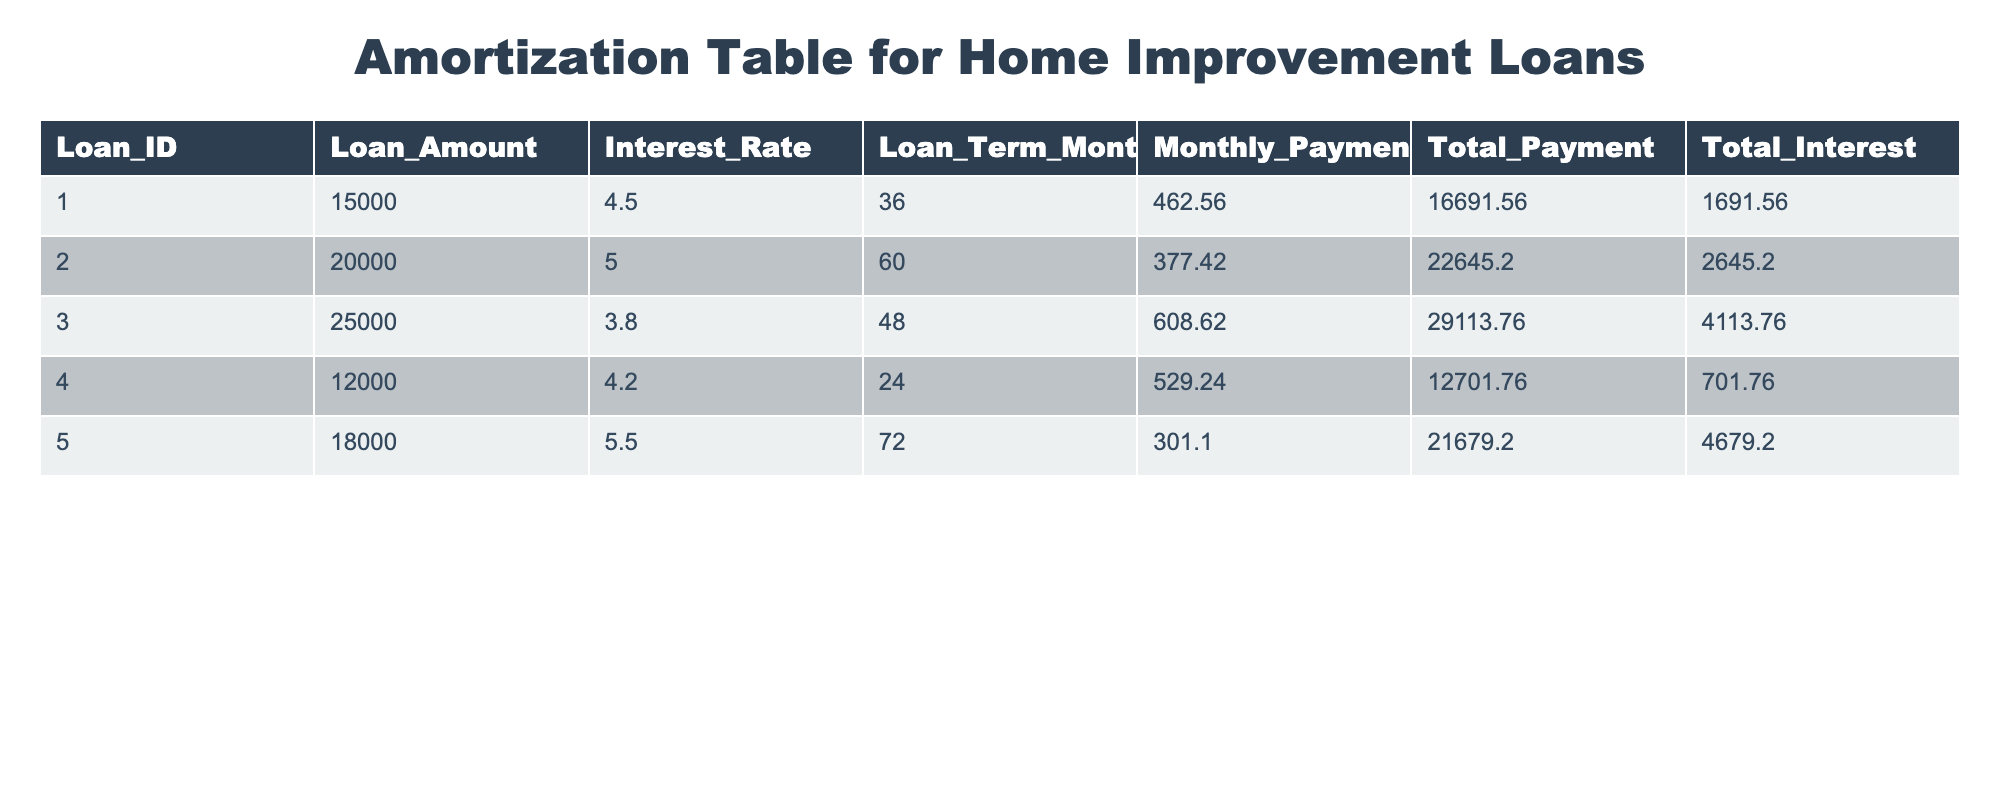What is the loan amount for Loan ID 3? From the table, we look for the row corresponding to Loan ID 3, which shows the Loan Amount as 25000.
Answer: 25000 What is the total interest paid on Loan ID 5? Referring to Loan ID 5 in the table, we see that the Total Interest is 4679.20.
Answer: 4679.20 Which loan has the highest total payment? By comparing the Total Payment values in the table, Loan ID 5 has the highest total payment of 21679.20.
Answer: Loan ID 5 Is the interest rate for Loan ID 2 higher than for Loan ID 1? Looking at the Interest Rate column, Loan ID 2 has an interest rate of 5.0, while Loan ID 1 has 4.5. Since 5.0 is greater than 4.5, the statement is true.
Answer: Yes What is the average monthly payment for all loans listed? To find the average, we sum the Monthly Payment values (462.56 + 377.42 + 608.62 + 529.24 + 301.10 = 2279.94) and divide by the number of loans (5). This gives us an average of 2279.94 / 5 = 455.988, which rounds to roughly 456.
Answer: 456 How much more total interest is paid on Loan ID 3 compared to Loan ID 4? Total Interest for Loan ID 3 is 4113.76, and for Loan ID 4, it is 701.76. The difference is 4113.76 - 701.76 = 3412.00.
Answer: 3412.00 What is the total loan amount for all loans with a term of 60 months or more? We identify Loans ID 2 and 5 as having terms of 60 or more months. Their amounts are 20000 and 18000, respectively. Summing these gives us 20000 + 18000 = 38000.
Answer: 38000 Which loan had the lowest interest rate, and what was it? By examining the Interest Rate column, Loan ID 3 has the lowest interest rate at 3.8%.
Answer: Loan ID 3, 3.8% Is it true that the total payment for Loan ID 1 exceeds 15000? Checking the Total Payment for Loan ID 1, which is 16691.56, confirms that it exceeds 15000. Therefore, the statement is true.
Answer: Yes 